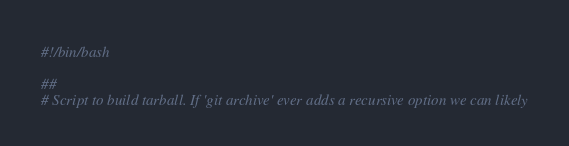<code> <loc_0><loc_0><loc_500><loc_500><_Bash_>#!/bin/bash

##
# Script to build tarball. If 'git archive' ever adds a recursive option we can likely </code> 